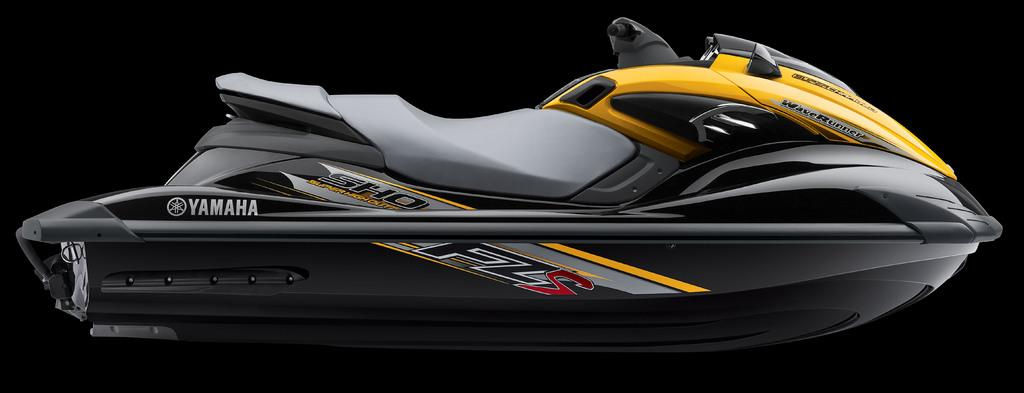What type of vehicle is in the picture? There is a waverunner boat in the picture. What colors are used for the boat? The boat is in black and yellow color. What can be observed about the background of the image? The background of the image is dark. What type of meal is being prepared on the boat in the image? There is no meal being prepared on the boat in the image; it is a waverunner boat, not a kitchen or dining area. 